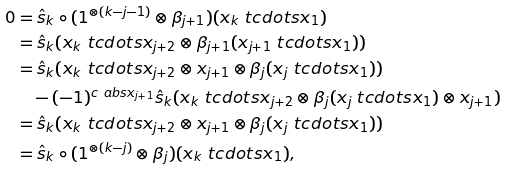<formula> <loc_0><loc_0><loc_500><loc_500>0 & = \hat { s } _ { k } \circ ( 1 ^ { \otimes ( k - j - 1 ) } \otimes \beta _ { j + 1 } ) ( x _ { k } \ t c d o t s x _ { 1 } ) \\ & = \hat { s } _ { k } ( x _ { k } \ t c d o t s x _ { j + 2 } \otimes \beta _ { j + 1 } ( x _ { j + 1 } \ t c d o t s x _ { 1 } ) ) \\ & = \hat { s } _ { k } ( x _ { k } \ t c d o t s x _ { j + 2 } \otimes x _ { j + 1 } \otimes \beta _ { j } ( x _ { j } \ t c d o t s x _ { 1 } ) ) \\ & \quad - ( - 1 ) ^ { c \ a b s { x _ { j + 1 } } } \hat { s } _ { k } ( x _ { k } \ t c d o t s x _ { j + 2 } \otimes \beta _ { j } ( x _ { j } \ t c d o t s x _ { 1 } ) \otimes x _ { j + 1 } ) \\ & = \hat { s } _ { k } ( x _ { k } \ t c d o t s x _ { j + 2 } \otimes x _ { j + 1 } \otimes \beta _ { j } ( x _ { j } \ t c d o t s x _ { 1 } ) ) \\ & = \hat { s } _ { k } \circ ( 1 ^ { \otimes ( k - j ) } \otimes \beta _ { j } ) ( x _ { k } \ t c d o t s x _ { 1 } ) ,</formula> 